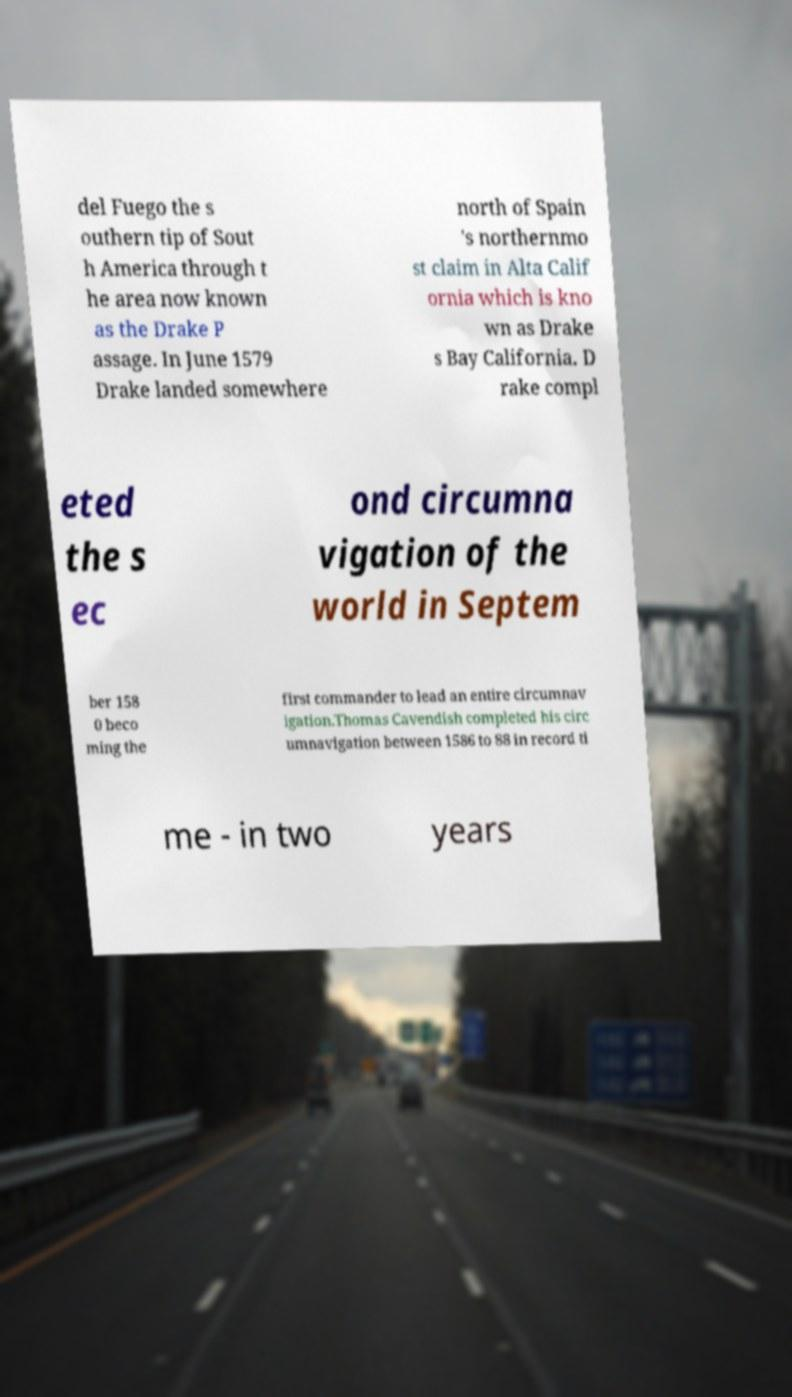Could you assist in decoding the text presented in this image and type it out clearly? del Fuego the s outhern tip of Sout h America through t he area now known as the Drake P assage. In June 1579 Drake landed somewhere north of Spain 's northernmo st claim in Alta Calif ornia which is kno wn as Drake s Bay California. D rake compl eted the s ec ond circumna vigation of the world in Septem ber 158 0 beco ming the first commander to lead an entire circumnav igation.Thomas Cavendish completed his circ umnavigation between 1586 to 88 in record ti me - in two years 